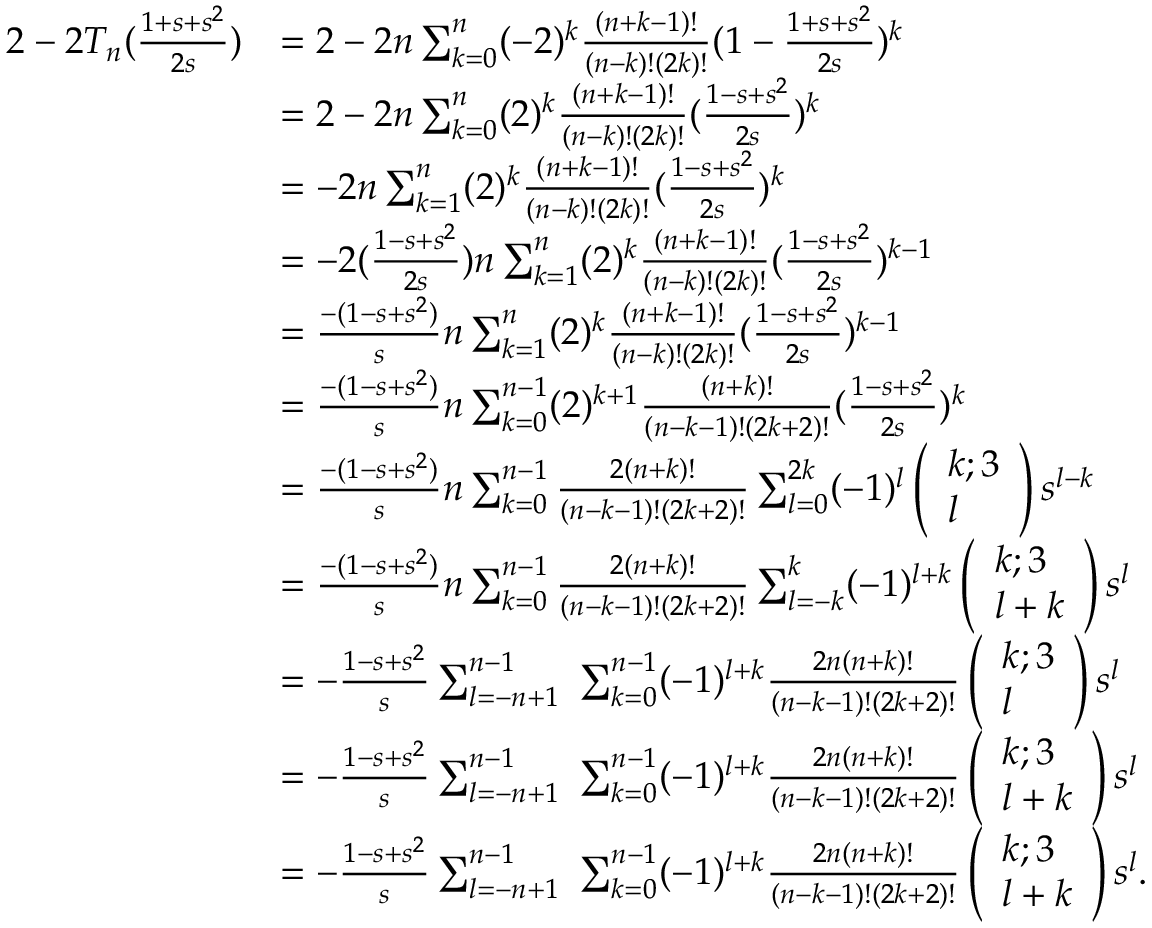Convert formula to latex. <formula><loc_0><loc_0><loc_500><loc_500>\begin{array} { r l } { 2 - 2 T _ { n } ( \frac { 1 + s + s ^ { 2 } } { 2 s } ) } & { = 2 - 2 n \sum _ { k = 0 } ^ { n } ( - 2 ) ^ { k } \frac { ( n + k - 1 ) ! } { ( n - k ) ! ( 2 k ) ! } ( 1 - \frac { 1 + s + s ^ { 2 } } { 2 s } ) ^ { k } } \\ & { = 2 - 2 n \sum _ { k = 0 } ^ { n } ( 2 ) ^ { k } \frac { ( n + k - 1 ) ! } { ( n - k ) ! ( 2 k ) ! } ( \frac { 1 - s + s ^ { 2 } } { 2 s } ) ^ { k } } \\ & { = - 2 n \sum _ { k = 1 } ^ { n } ( 2 ) ^ { k } \frac { ( n + k - 1 ) ! } { ( n - k ) ! ( 2 k ) ! } ( \frac { 1 - s + s ^ { 2 } } { 2 s } ) ^ { k } } \\ & { = - 2 ( \frac { 1 - s + s ^ { 2 } } { 2 s } ) n \sum _ { k = 1 } ^ { n } ( 2 ) ^ { k } \frac { ( n + k - 1 ) ! } { ( n - k ) ! ( 2 k ) ! } ( \frac { 1 - s + s ^ { 2 } } { 2 s } ) ^ { k - 1 } } \\ & { = \frac { - ( 1 - s + s ^ { 2 } ) } { s } n \sum _ { k = 1 } ^ { n } ( 2 ) ^ { k } \frac { ( n + k - 1 ) ! } { ( n - k ) ! ( 2 k ) ! } ( \frac { 1 - s + s ^ { 2 } } { 2 s } ) ^ { k - 1 } } \\ & { = \frac { - ( 1 - s + s ^ { 2 } ) } { s } n \sum _ { k = 0 } ^ { n - 1 } ( 2 ) ^ { k + 1 } \frac { ( n + k ) ! } { ( n - k - 1 ) ! ( 2 k + 2 ) ! } ( \frac { 1 - s + s ^ { 2 } } { 2 s } ) ^ { k } } \\ & { = \frac { - ( 1 - s + s ^ { 2 } ) } { s } n \sum _ { k = 0 } ^ { n - 1 } \frac { 2 ( n + k ) ! } { ( n - k - 1 ) ! ( 2 k + 2 ) ! } \sum _ { l = 0 } ^ { 2 k } ( - 1 ) ^ { l } \left ( \begin{array} { l } { k ; 3 } \\ { l } \end{array} \right ) s ^ { l - k } } \\ & { = \frac { - ( 1 - s + s ^ { 2 } ) } { s } n \sum _ { k = 0 } ^ { n - 1 } \frac { 2 ( n + k ) ! } { ( n - k - 1 ) ! ( 2 k + 2 ) ! } \sum _ { l = - k } ^ { k } ( - 1 ) ^ { l + k } \left ( \begin{array} { l } { k ; 3 } \\ { l + k } \end{array} \right ) s ^ { l } } \\ & { = - \frac { 1 - s + s ^ { 2 } } { s } \sum _ { l = - n + 1 } ^ { n - 1 } \ \sum _ { k = 0 } ^ { n - 1 } ( - 1 ) ^ { l + k } \frac { 2 n ( n + k ) ! } { ( n - k - 1 ) ! ( 2 k + 2 ) ! } \left ( \begin{array} { l } { k ; 3 } \\ { l } \end{array} \right ) s ^ { l } } \\ & { = - \frac { 1 - s + s ^ { 2 } } { s } \sum _ { l = - n + 1 } ^ { n - 1 } \ \sum _ { k = 0 } ^ { n - 1 } ( - 1 ) ^ { l + k } \frac { 2 n ( n + k ) ! } { ( n - k - 1 ) ! ( 2 k + 2 ) ! } \left ( \begin{array} { l } { k ; 3 } \\ { l + k } \end{array} \right ) s ^ { l } } \\ & { = - \frac { 1 - s + s ^ { 2 } } { s } \sum _ { l = - n + 1 } ^ { n - 1 } \ \sum _ { k = 0 } ^ { n - 1 } ( - 1 ) ^ { l + k } \frac { 2 n ( n + k ) ! } { ( n - k - 1 ) ! ( 2 k + 2 ) ! } \left ( \begin{array} { l } { k ; 3 } \\ { l + k } \end{array} \right ) s ^ { l } . } \end{array}</formula> 